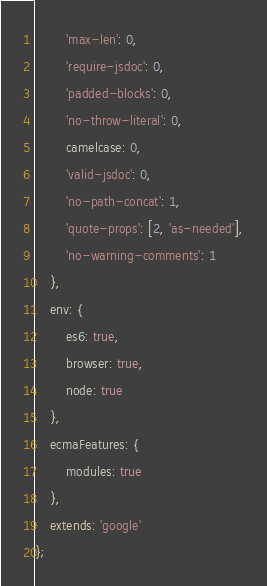<code> <loc_0><loc_0><loc_500><loc_500><_JavaScript_>        'max-len': 0,
        'require-jsdoc': 0,
        'padded-blocks': 0,
        'no-throw-literal': 0,
        camelcase: 0,
        'valid-jsdoc': 0,
        'no-path-concat': 1,
        'quote-props': [2, 'as-needed'],
        'no-warning-comments': 1
    },
    env: {
        es6: true,
        browser: true,
        node: true
    },
    ecmaFeatures: {
        modules: true
    },
    extends: 'google'
};
</code> 